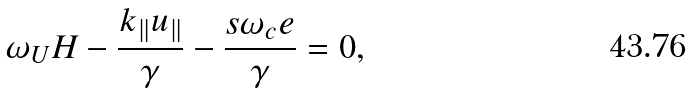Convert formula to latex. <formula><loc_0><loc_0><loc_500><loc_500>\omega _ { U } H - \frac { k _ { \| } u _ { \| } } { \gamma } - \frac { s \omega _ { c } e } { \gamma } = 0 ,</formula> 